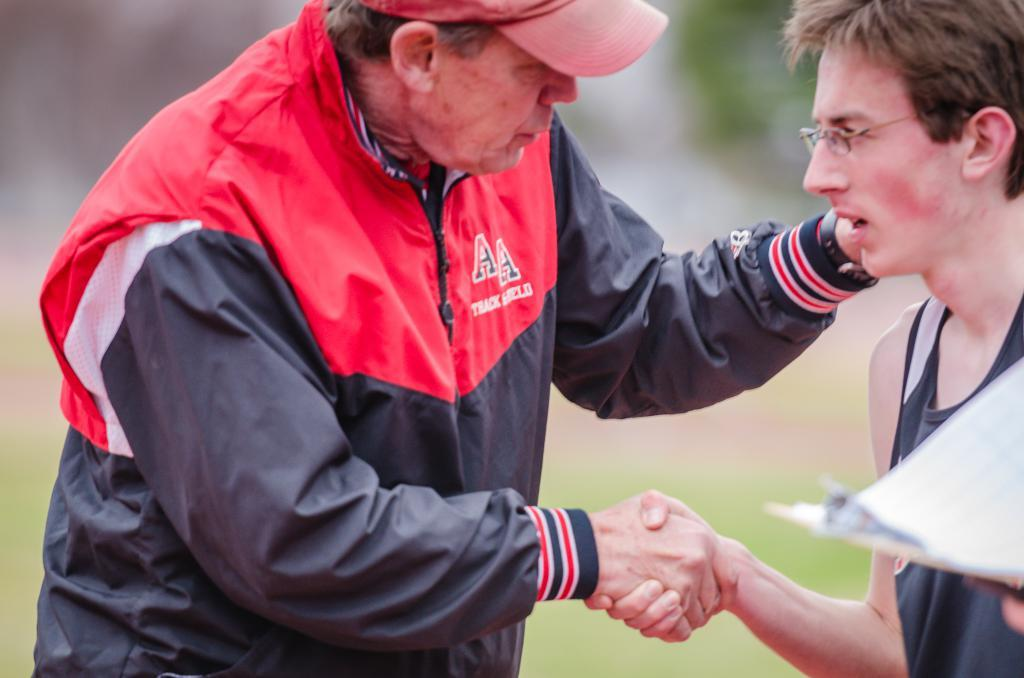How many people are in the image? There are two persons in the image. What are the two persons doing in the image? The two persons are standing and shaking hands. Can you describe the background of the image? The background of the image is blurred. What type of popcorn is being served at the event in the image? There is no event or popcorn present in the image; it features two persons shaking hands. How many legs can be seen in the image? The image only shows two persons, and each person has two legs, making a total of four legs visible. However, this question is not directly answerable from the provided facts, as it focuses on a detail that is not mentioned. 